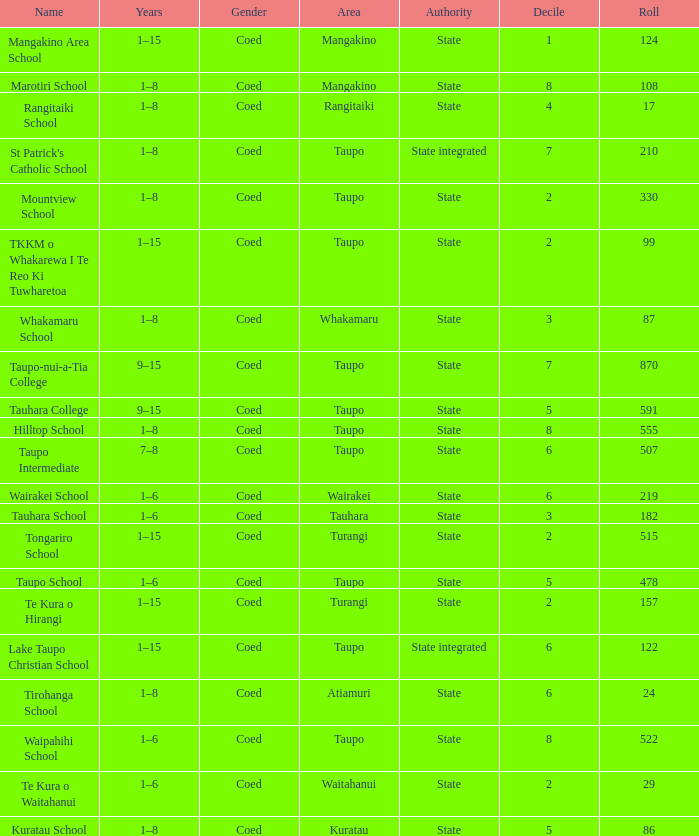Where is the school with state authority that has a roll of more than 157 students? Taupo, Taupo, Taupo, Tauhara, Taupo, Taupo, Taupo, Turangi, Taupo, Wairakei. Help me parse the entirety of this table. {'header': ['Name', 'Years', 'Gender', 'Area', 'Authority', 'Decile', 'Roll'], 'rows': [['Mangakino Area School', '1–15', 'Coed', 'Mangakino', 'State', '1', '124'], ['Marotiri School', '1–8', 'Coed', 'Mangakino', 'State', '8', '108'], ['Rangitaiki School', '1–8', 'Coed', 'Rangitaiki', 'State', '4', '17'], ["St Patrick's Catholic School", '1–8', 'Coed', 'Taupo', 'State integrated', '7', '210'], ['Mountview School', '1–8', 'Coed', 'Taupo', 'State', '2', '330'], ['TKKM o Whakarewa I Te Reo Ki Tuwharetoa', '1–15', 'Coed', 'Taupo', 'State', '2', '99'], ['Whakamaru School', '1–8', 'Coed', 'Whakamaru', 'State', '3', '87'], ['Taupo-nui-a-Tia College', '9–15', 'Coed', 'Taupo', 'State', '7', '870'], ['Tauhara College', '9–15', 'Coed', 'Taupo', 'State', '5', '591'], ['Hilltop School', '1–8', 'Coed', 'Taupo', 'State', '8', '555'], ['Taupo Intermediate', '7–8', 'Coed', 'Taupo', 'State', '6', '507'], ['Wairakei School', '1–6', 'Coed', 'Wairakei', 'State', '6', '219'], ['Tauhara School', '1–6', 'Coed', 'Tauhara', 'State', '3', '182'], ['Tongariro School', '1–15', 'Coed', 'Turangi', 'State', '2', '515'], ['Taupo School', '1–6', 'Coed', 'Taupo', 'State', '5', '478'], ['Te Kura o Hirangi', '1–15', 'Coed', 'Turangi', 'State', '2', '157'], ['Lake Taupo Christian School', '1–15', 'Coed', 'Taupo', 'State integrated', '6', '122'], ['Tirohanga School', '1–8', 'Coed', 'Atiamuri', 'State', '6', '24'], ['Waipahihi School', '1–6', 'Coed', 'Taupo', 'State', '8', '522'], ['Te Kura o Waitahanui', '1–6', 'Coed', 'Waitahanui', 'State', '2', '29'], ['Kuratau School', '1–8', 'Coed', 'Kuratau', 'State', '5', '86']]} 